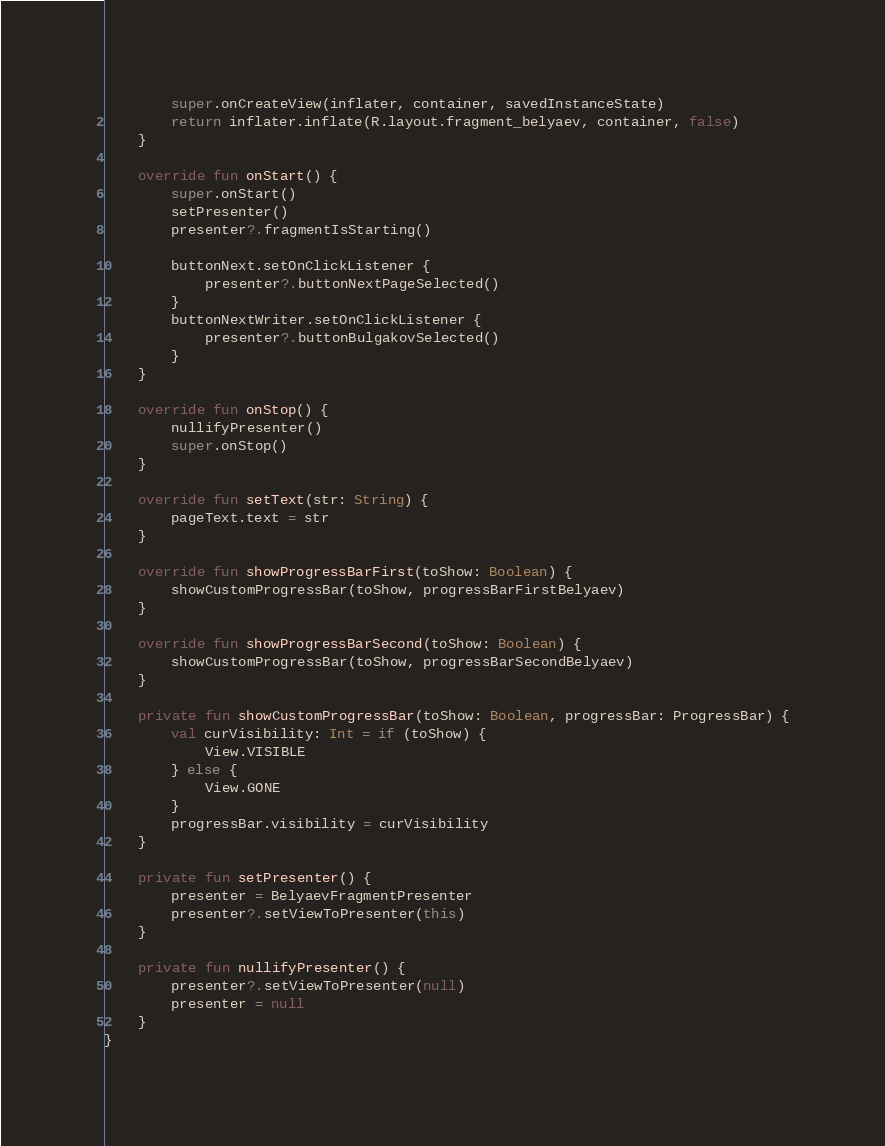<code> <loc_0><loc_0><loc_500><loc_500><_Kotlin_>        super.onCreateView(inflater, container, savedInstanceState)
        return inflater.inflate(R.layout.fragment_belyaev, container, false)
    }

    override fun onStart() {
        super.onStart()
        setPresenter()
        presenter?.fragmentIsStarting()

        buttonNext.setOnClickListener {
            presenter?.buttonNextPageSelected()
        }
        buttonNextWriter.setOnClickListener {
            presenter?.buttonBulgakovSelected()
        }
    }

    override fun onStop() {
        nullifyPresenter()
        super.onStop()
    }

    override fun setText(str: String) {
        pageText.text = str
    }

    override fun showProgressBarFirst(toShow: Boolean) {
        showCustomProgressBar(toShow, progressBarFirstBelyaev)
    }

    override fun showProgressBarSecond(toShow: Boolean) {
        showCustomProgressBar(toShow, progressBarSecondBelyaev)
    }

    private fun showCustomProgressBar(toShow: Boolean, progressBar: ProgressBar) {
        val curVisibility: Int = if (toShow) {
            View.VISIBLE
        } else {
            View.GONE
        }
        progressBar.visibility = curVisibility
    }

    private fun setPresenter() {
        presenter = BelyaevFragmentPresenter
        presenter?.setViewToPresenter(this)
    }

    private fun nullifyPresenter() {
        presenter?.setViewToPresenter(null)
        presenter = null
    }
}</code> 